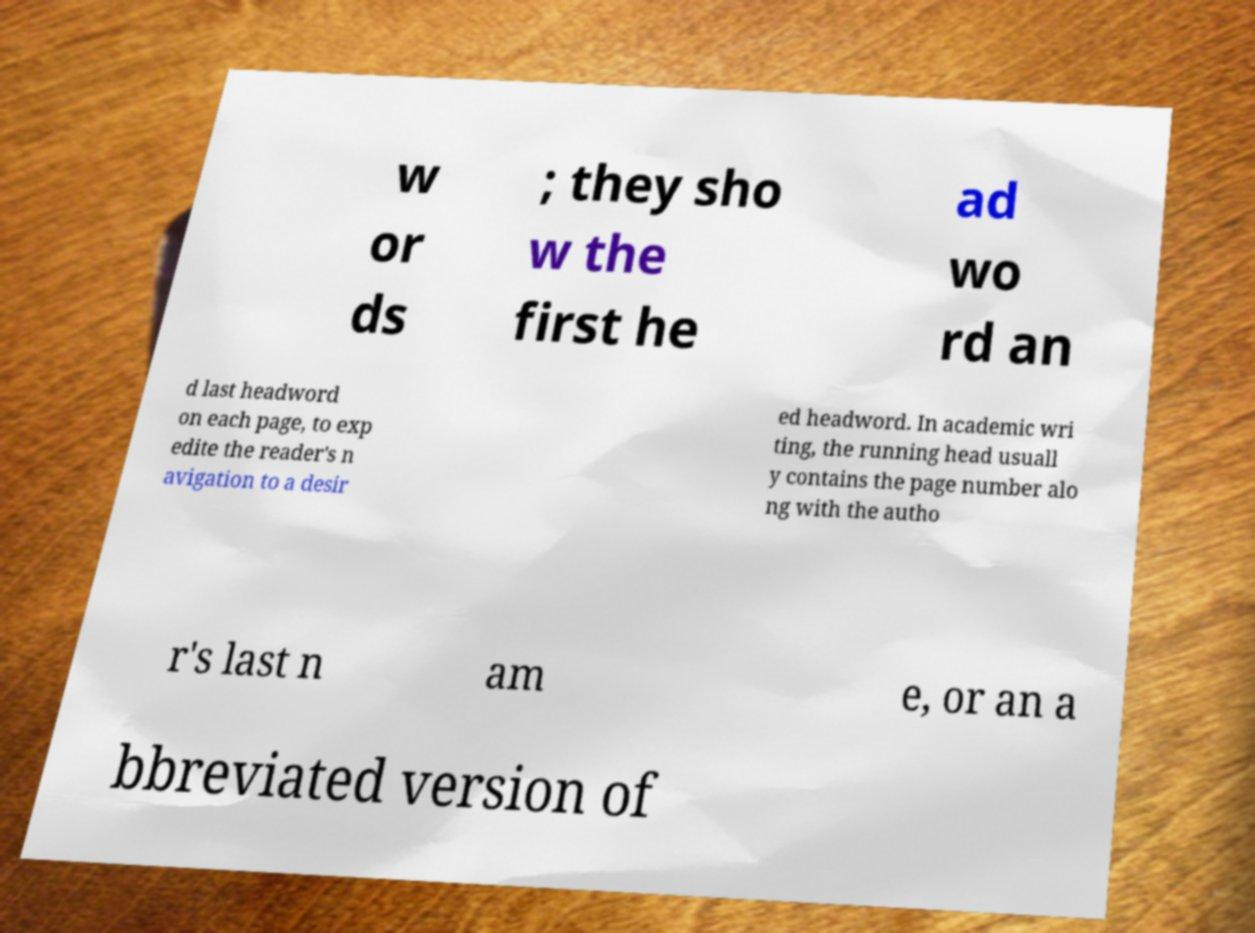What messages or text are displayed in this image? I need them in a readable, typed format. w or ds ; they sho w the first he ad wo rd an d last headword on each page, to exp edite the reader's n avigation to a desir ed headword. In academic wri ting, the running head usuall y contains the page number alo ng with the autho r's last n am e, or an a bbreviated version of 